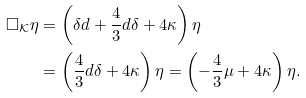<formula> <loc_0><loc_0><loc_500><loc_500>\square _ { \mathcal { K } } \eta & = \left ( \delta d + \frac { 4 } { 3 } d \delta + 4 \kappa \right ) \eta \\ & = \left ( \frac { 4 } { 3 } d \delta + 4 \kappa \right ) \eta = \left ( - \frac { 4 } { 3 } \mu + 4 \kappa \right ) \eta .</formula> 